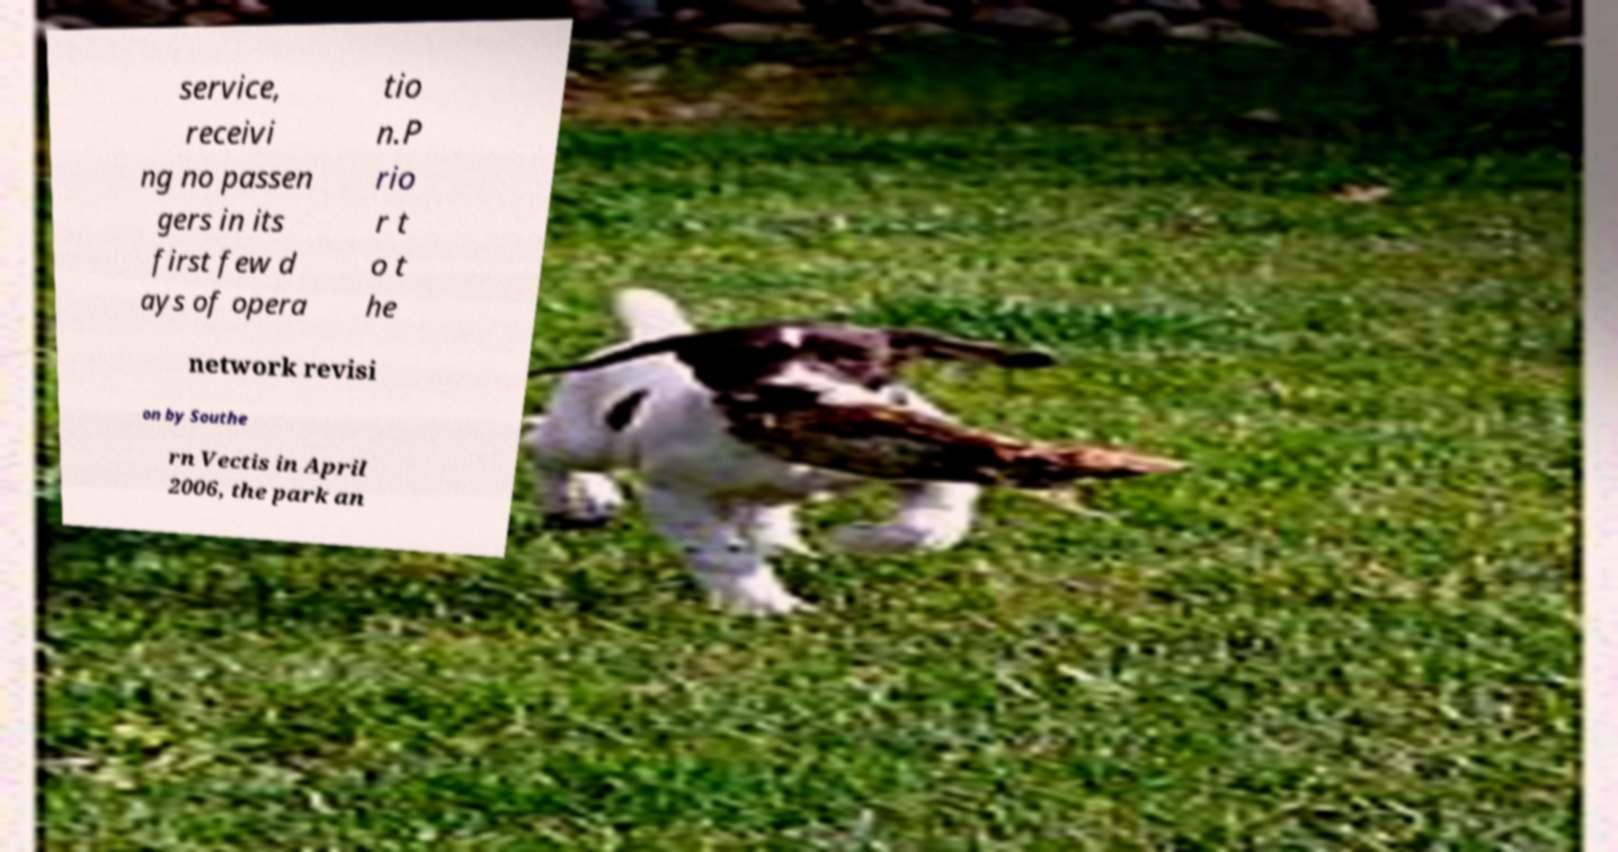Can you accurately transcribe the text from the provided image for me? service, receivi ng no passen gers in its first few d ays of opera tio n.P rio r t o t he network revisi on by Southe rn Vectis in April 2006, the park an 